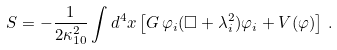Convert formula to latex. <formula><loc_0><loc_0><loc_500><loc_500>S = - \frac { 1 } { 2 \kappa _ { 1 0 } ^ { 2 } } \int d ^ { 4 } x \left [ G \, \varphi _ { i } ( \Box + \lambda _ { i } ^ { 2 } ) \varphi _ { i } + V ( \varphi ) \right ] \, .</formula> 